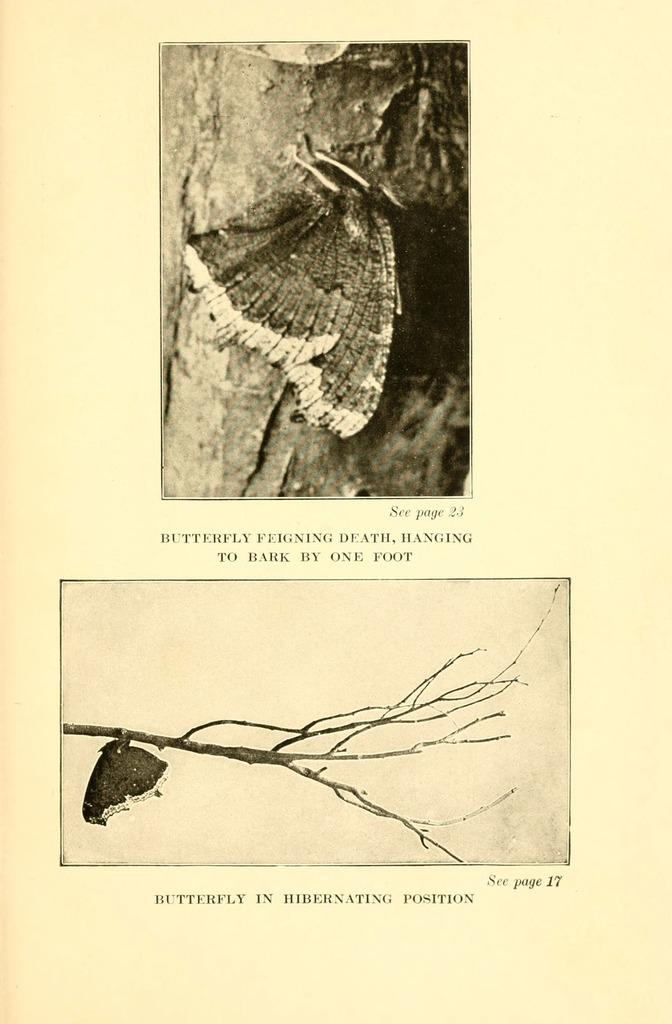How many images are present on the page? There are two images on the page. What is depicted in the images? The images contain butterflies on a branch. Is there any text accompanying the images? Yes, there is text written on the page. How many cakes are shown in the images? There are no cakes present in the images; they depict butterflies on a branch. What type of flowers can be seen in the images? There are no flowers depicted in the images; they feature butterflies on a branch. 